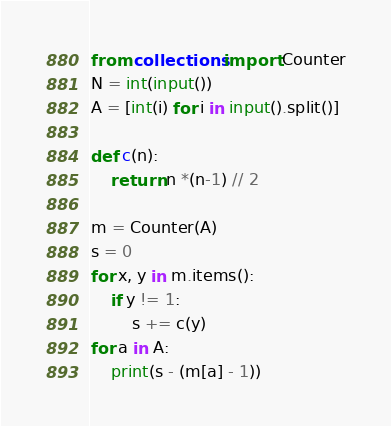Convert code to text. <code><loc_0><loc_0><loc_500><loc_500><_Python_>from collections import Counter
N = int(input())
A = [int(i) for i in input().split()]

def c(n):
    return n *(n-1) // 2

m = Counter(A)
s = 0
for x, y in m.items():
    if y != 1:
        s += c(y)
for a in A:
    print(s - (m[a] - 1))</code> 